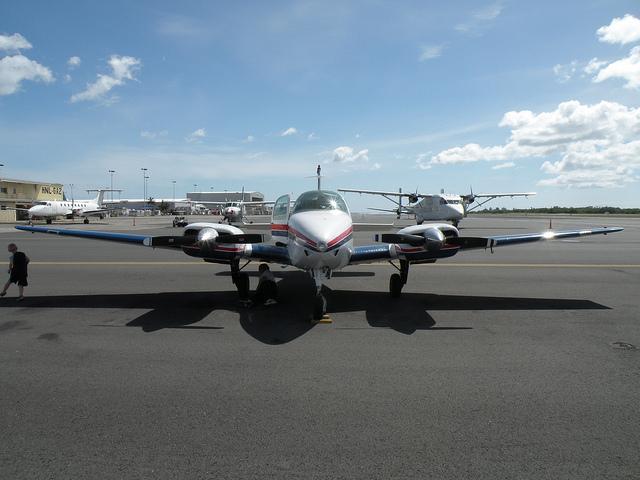Is this an f 16?
Keep it brief. No. How many airplanes are there in this image?
Short answer required. 4. Does this look like a dangerous day to fly?
Keep it brief. No. Are there safety cones visible in the picture?
Keep it brief. No. Is the plane facing toward the camera?
Write a very short answer. Yes. Is this a modern day photo?
Answer briefly. Yes. 